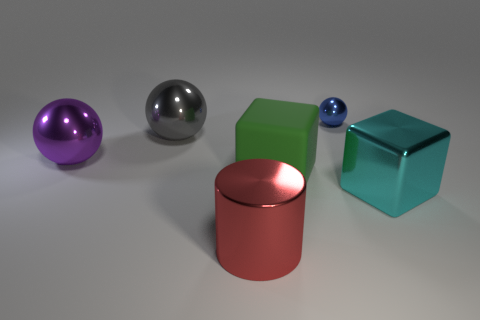Subtract all big balls. How many balls are left? 1 Add 2 blue things. How many objects exist? 8 Subtract all blocks. How many objects are left? 4 Subtract 0 purple cylinders. How many objects are left? 6 Subtract all small green metal blocks. Subtract all big green matte blocks. How many objects are left? 5 Add 1 big red objects. How many big red objects are left? 2 Add 4 tiny red matte cubes. How many tiny red matte cubes exist? 4 